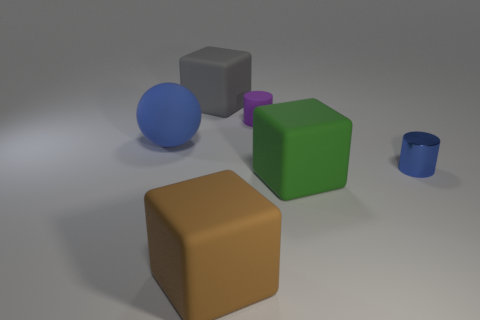What number of tiny objects are red cylinders or metal cylinders?
Your answer should be very brief. 1. How many things are either large blocks that are on the left side of the large brown matte block or big blocks behind the small shiny object?
Your answer should be very brief. 1. Is the number of rubber objects less than the number of green things?
Give a very brief answer. No. What shape is the matte object that is the same size as the blue cylinder?
Give a very brief answer. Cylinder. How many other objects are there of the same color as the tiny metallic cylinder?
Make the answer very short. 1. How many small blue metallic balls are there?
Provide a short and direct response. 0. What number of rubber things are both behind the tiny metallic thing and in front of the large gray rubber cube?
Ensure brevity in your answer.  2. What is the tiny purple object made of?
Your response must be concise. Rubber. Are any large green cubes visible?
Your response must be concise. Yes. There is a small object behind the blue cylinder; what is its color?
Provide a succinct answer. Purple. 